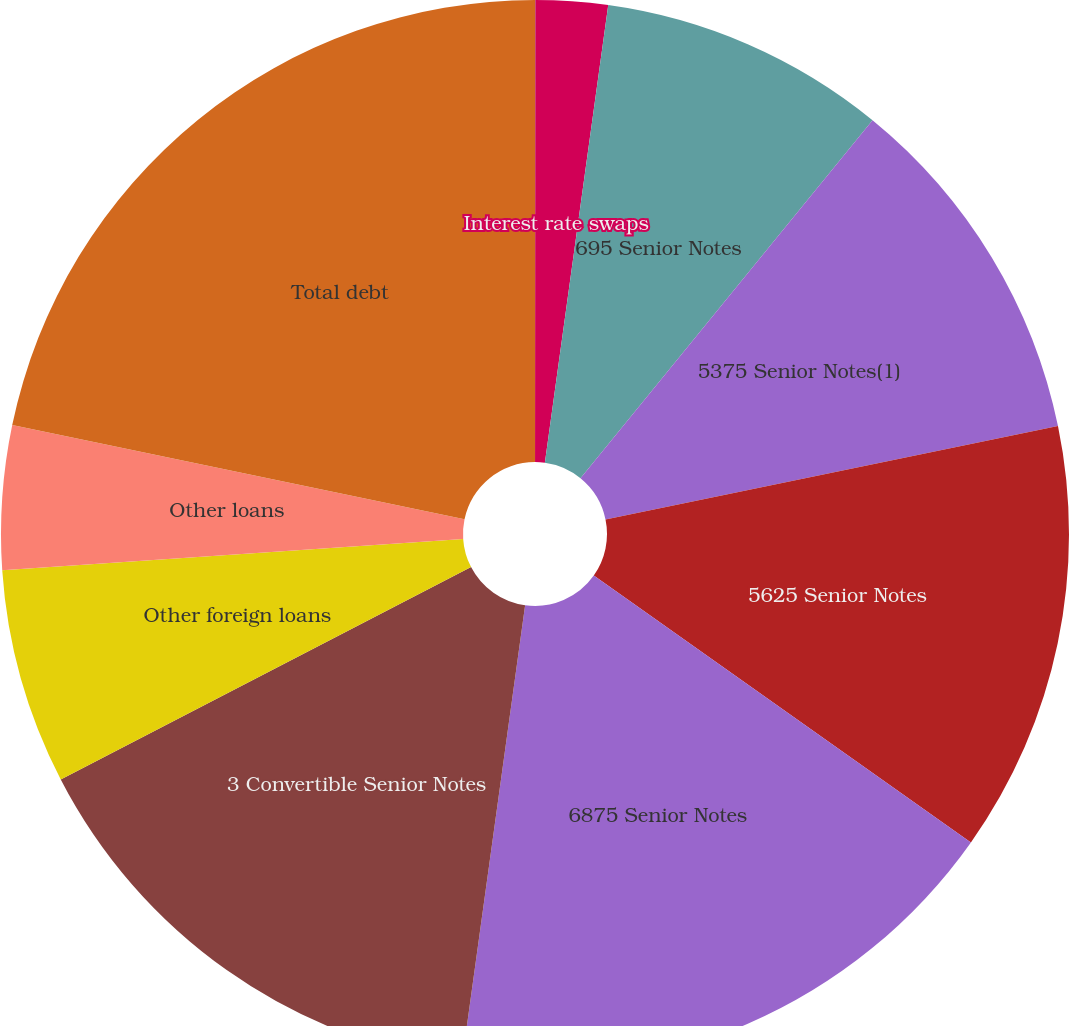Convert chart to OTSL. <chart><loc_0><loc_0><loc_500><loc_500><pie_chart><fcel>Foreign currency forward<fcel>Interest rate swaps<fcel>695 Senior Notes<fcel>5375 Senior Notes(1)<fcel>5625 Senior Notes<fcel>6875 Senior Notes<fcel>3 Convertible Senior Notes<fcel>Other foreign loans<fcel>Other loans<fcel>Total debt<nl><fcel>0.01%<fcel>2.18%<fcel>8.7%<fcel>10.87%<fcel>13.04%<fcel>17.39%<fcel>15.21%<fcel>6.52%<fcel>4.35%<fcel>21.73%<nl></chart> 